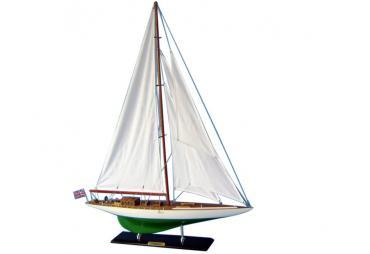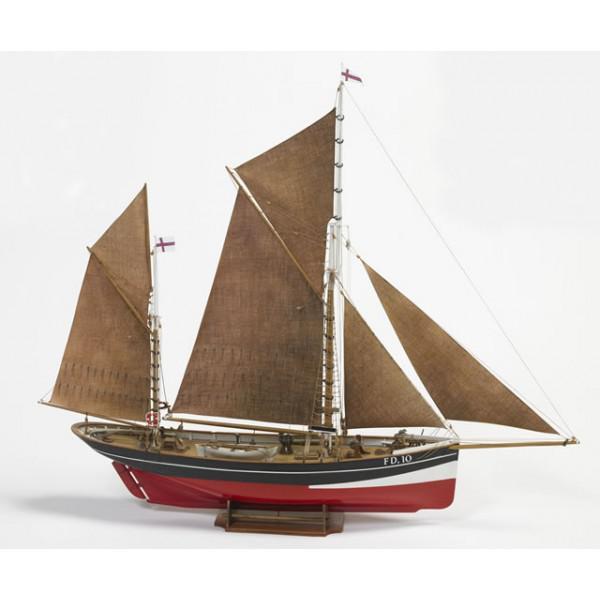The first image is the image on the left, the second image is the image on the right. Considering the images on both sides, is "A boat on the water with three inflated sails is facing left" valid? Answer yes or no. No. 